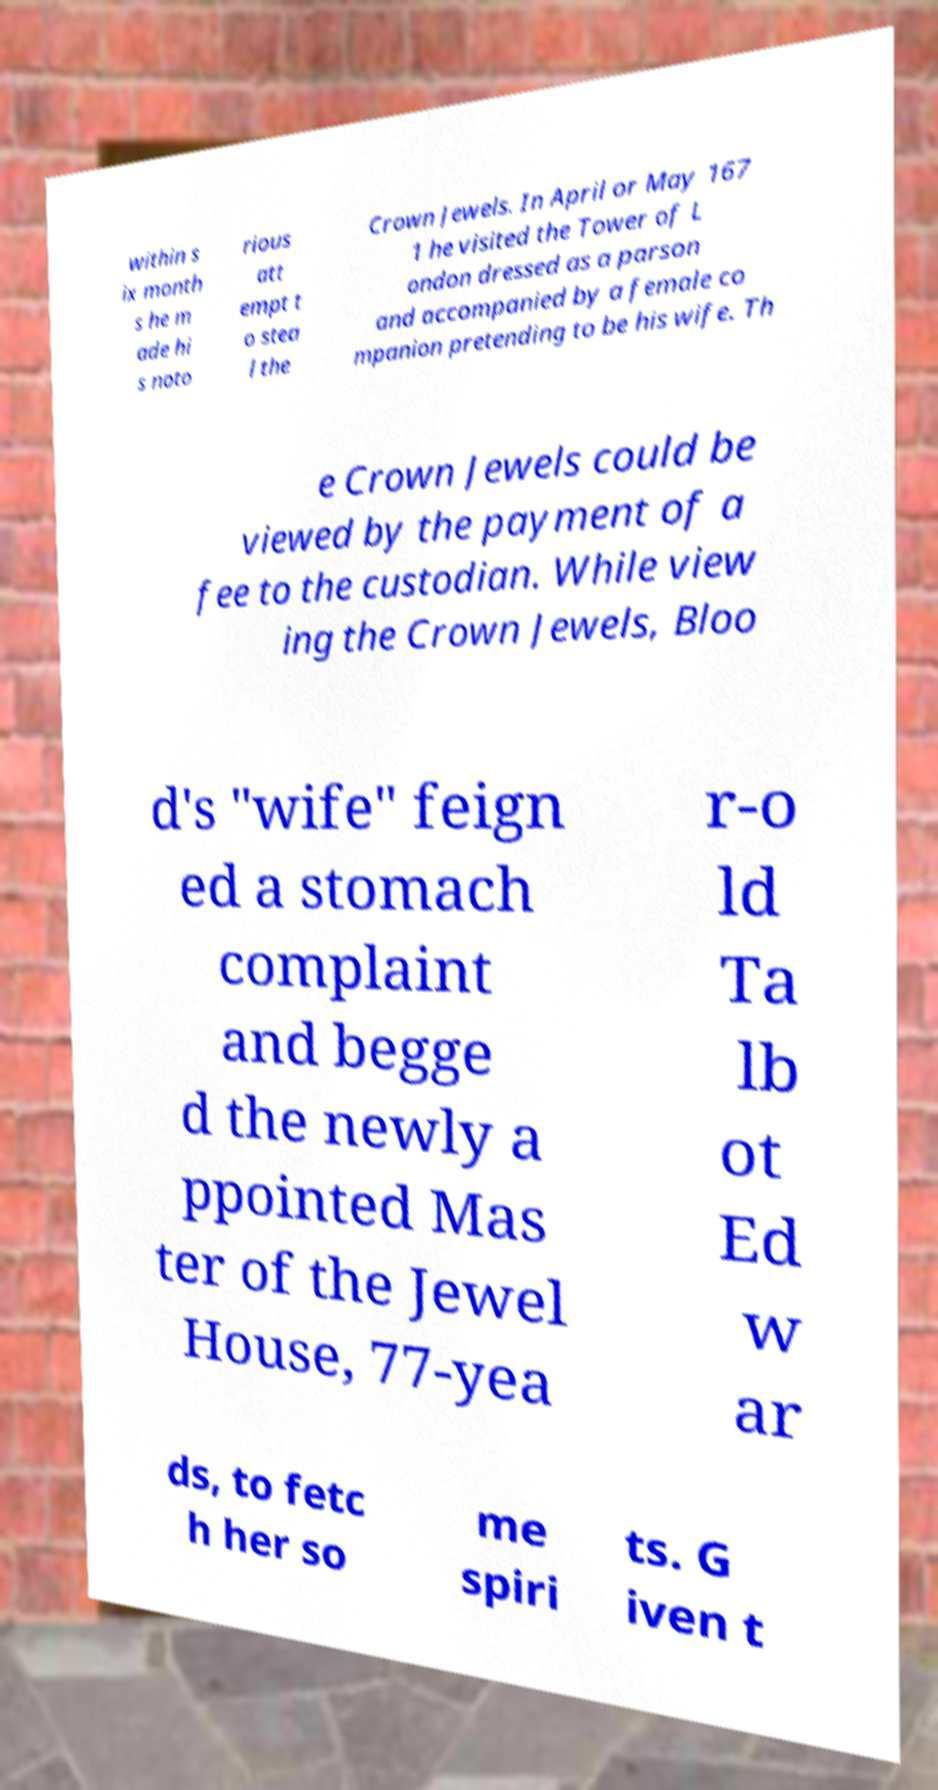Could you assist in decoding the text presented in this image and type it out clearly? within s ix month s he m ade hi s noto rious att empt t o stea l the Crown Jewels. In April or May 167 1 he visited the Tower of L ondon dressed as a parson and accompanied by a female co mpanion pretending to be his wife. Th e Crown Jewels could be viewed by the payment of a fee to the custodian. While view ing the Crown Jewels, Bloo d's "wife" feign ed a stomach complaint and begge d the newly a ppointed Mas ter of the Jewel House, 77-yea r-o ld Ta lb ot Ed w ar ds, to fetc h her so me spiri ts. G iven t 